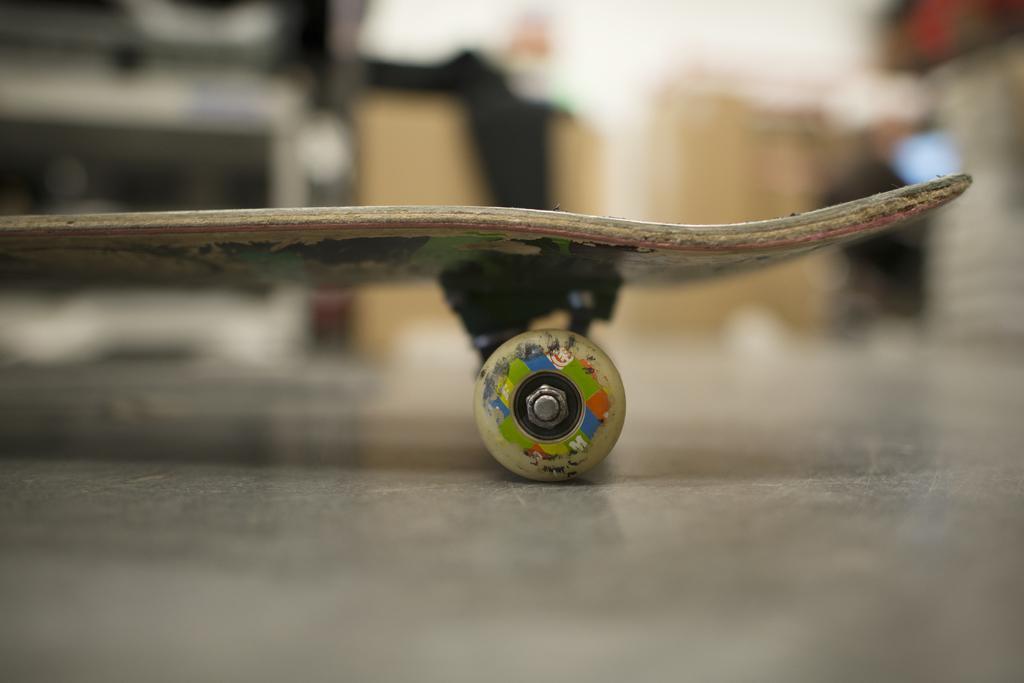How would you summarize this image in a sentence or two? In this image we can see there is a skateboard. The background is blurred. 